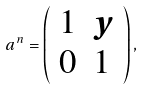<formula> <loc_0><loc_0><loc_500><loc_500>a ^ { n } = \left ( \begin{array} { r l } 1 & y \\ 0 & 1 \\ \end{array} \right ) ,</formula> 